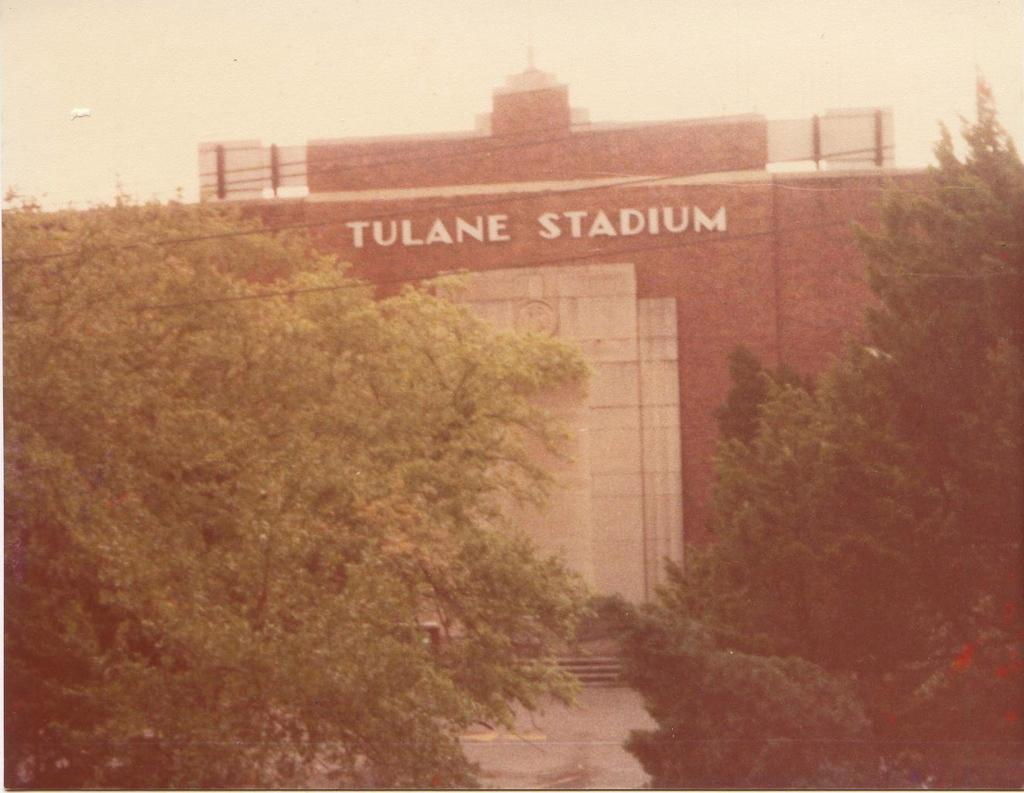What is the main subject of the image? The main subject of the image is Tulane stadium. What colors are used for the stadium walls? The stadium walls are in red and white colors. What can be seen in front of the stadium? There are trees in front of the stadium. Can you tell me how many corks are scattered on the ground in front of the stadium? There is no mention of corks in the image, so it is not possible to determine how many might be scattered on the ground. 